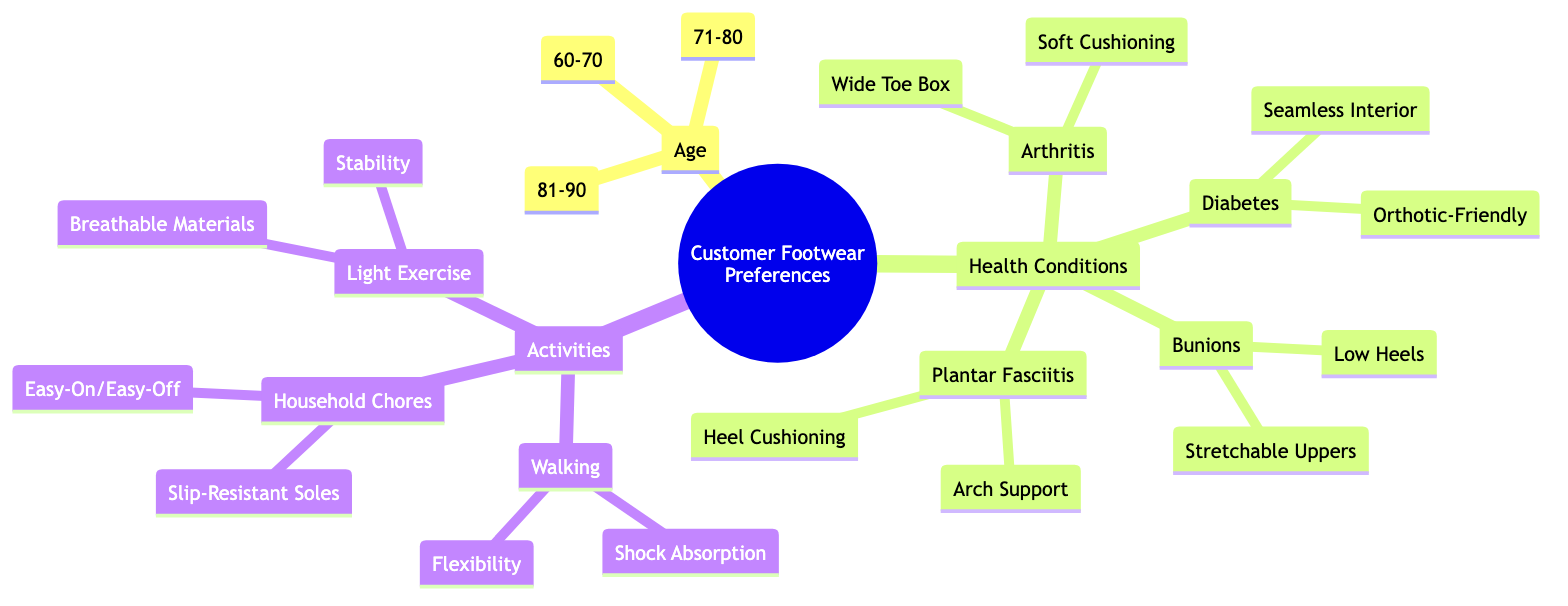What are the age groups listed in the diagram? The diagram lists three age groups under the "Age" node: 60-70, 71-80, and 81-90.
Answer: 60-70, 71-80, 81-90 What health condition is associated with "Stretchable Uppers"? The health condition that has "Stretchable Uppers" as a solution is Bunions, as indicated under the "Health Conditions" section.
Answer: Bunions How many features are listed for "Walking"? Under "Walking," there are two features listed: "Shock Absorption" and "Flexibility."
Answer: 2 Which age group corresponds to the highest range in the diagram? The highest age group listed in the diagram is 81-90, which is the last mentioned under the Age category.
Answer: 81-90 Which health condition has a solution that includes "Heel Cushioning"? "Heel Cushioning" is a solution for Plantar Fasciitis, as shown in the diagram under the section for health conditions.
Answer: Plantar Fasciitis What is one feature associated with "Light Exercise"? The feature associated with "Light Exercise" is "Breathable Materials," which is listed under that activity category in the diagram.
Answer: Breathable Materials What type of footwear feature is recommended for "Household Chores"? The recommended footwear features for "Household Chores" include "Slip-Resistant Soles" and "Easy-On/Easy-Off."
Answer: Slip-Resistant Soles Which activity corresponds with "Flexibility"? "Walking" corresponds with the feature "Flexibility" in the diagram, indicating a suitable footwear characteristic for this activity.
Answer: Walking How many common health issues are identified in the diagram? The diagram identifies four common health issues: Arthritis, Diabetes, Bunions, and Plantar Fasciitis, totaling four.
Answer: 4 